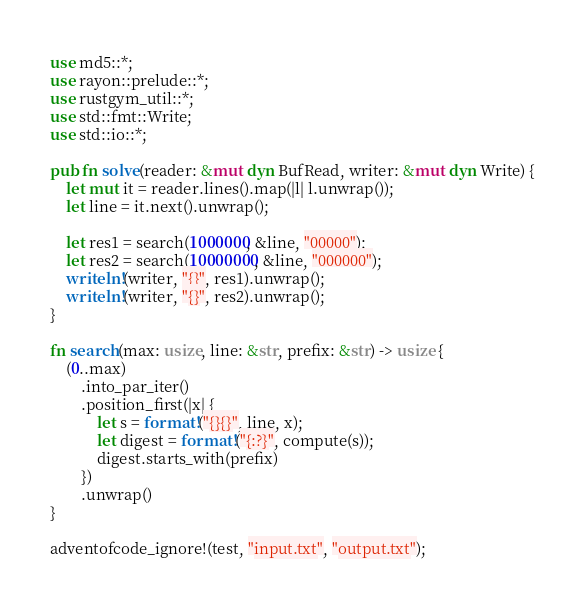<code> <loc_0><loc_0><loc_500><loc_500><_Rust_>use md5::*;
use rayon::prelude::*;
use rustgym_util::*;
use std::fmt::Write;
use std::io::*;

pub fn solve(reader: &mut dyn BufRead, writer: &mut dyn Write) {
    let mut it = reader.lines().map(|l| l.unwrap());
    let line = it.next().unwrap();

    let res1 = search(1000000, &line, "00000");
    let res2 = search(10000000, &line, "000000");
    writeln!(writer, "{}", res1).unwrap();
    writeln!(writer, "{}", res2).unwrap();
}

fn search(max: usize, line: &str, prefix: &str) -> usize {
    (0..max)
        .into_par_iter()
        .position_first(|x| {
            let s = format!("{}{}", line, x);
            let digest = format!("{:?}", compute(s));
            digest.starts_with(prefix)
        })
        .unwrap()
}

adventofcode_ignore!(test, "input.txt", "output.txt");
</code> 